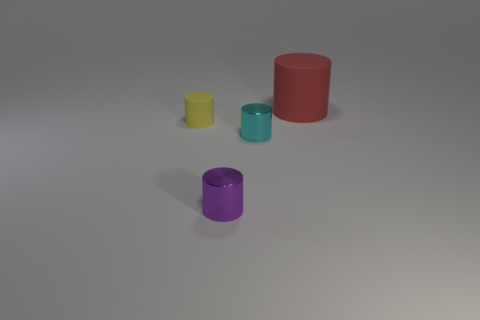Is there anything else that is the same size as the red cylinder?
Keep it short and to the point. No. Does the rubber cylinder that is right of the tiny rubber object have the same color as the small shiny object that is right of the purple object?
Provide a succinct answer. No. What is the material of the cylinder that is behind the yellow matte object?
Your response must be concise. Rubber. The small cylinder that is made of the same material as the large thing is what color?
Provide a succinct answer. Yellow. How many cyan shiny cylinders are the same size as the yellow matte cylinder?
Provide a short and direct response. 1. Does the matte cylinder in front of the red object have the same size as the large cylinder?
Your response must be concise. No. What shape is the thing that is behind the tiny cyan shiny cylinder and in front of the large red cylinder?
Keep it short and to the point. Cylinder. There is a large red cylinder; are there any big matte cylinders left of it?
Offer a terse response. No. Is there any other thing that has the same shape as the big matte thing?
Your answer should be compact. Yes. Is the shape of the small yellow thing the same as the small cyan metallic object?
Your response must be concise. Yes. 